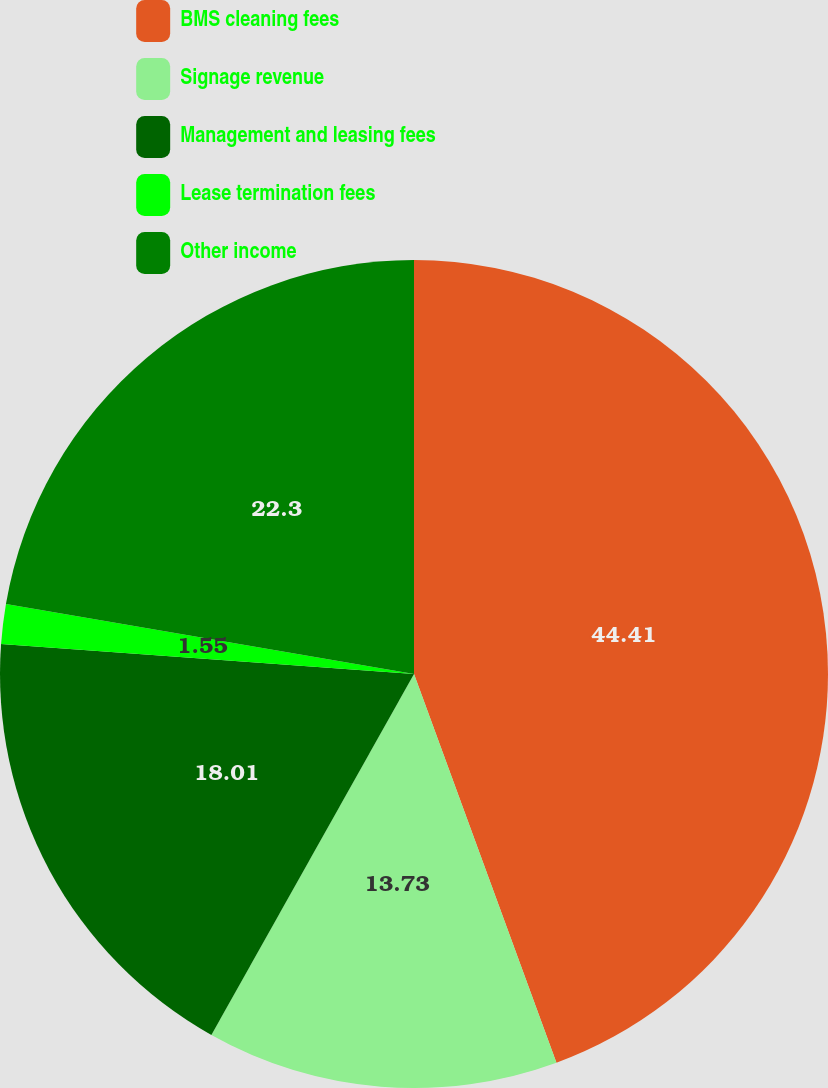<chart> <loc_0><loc_0><loc_500><loc_500><pie_chart><fcel>BMS cleaning fees<fcel>Signage revenue<fcel>Management and leasing fees<fcel>Lease termination fees<fcel>Other income<nl><fcel>44.41%<fcel>13.73%<fcel>18.01%<fcel>1.55%<fcel>22.3%<nl></chart> 